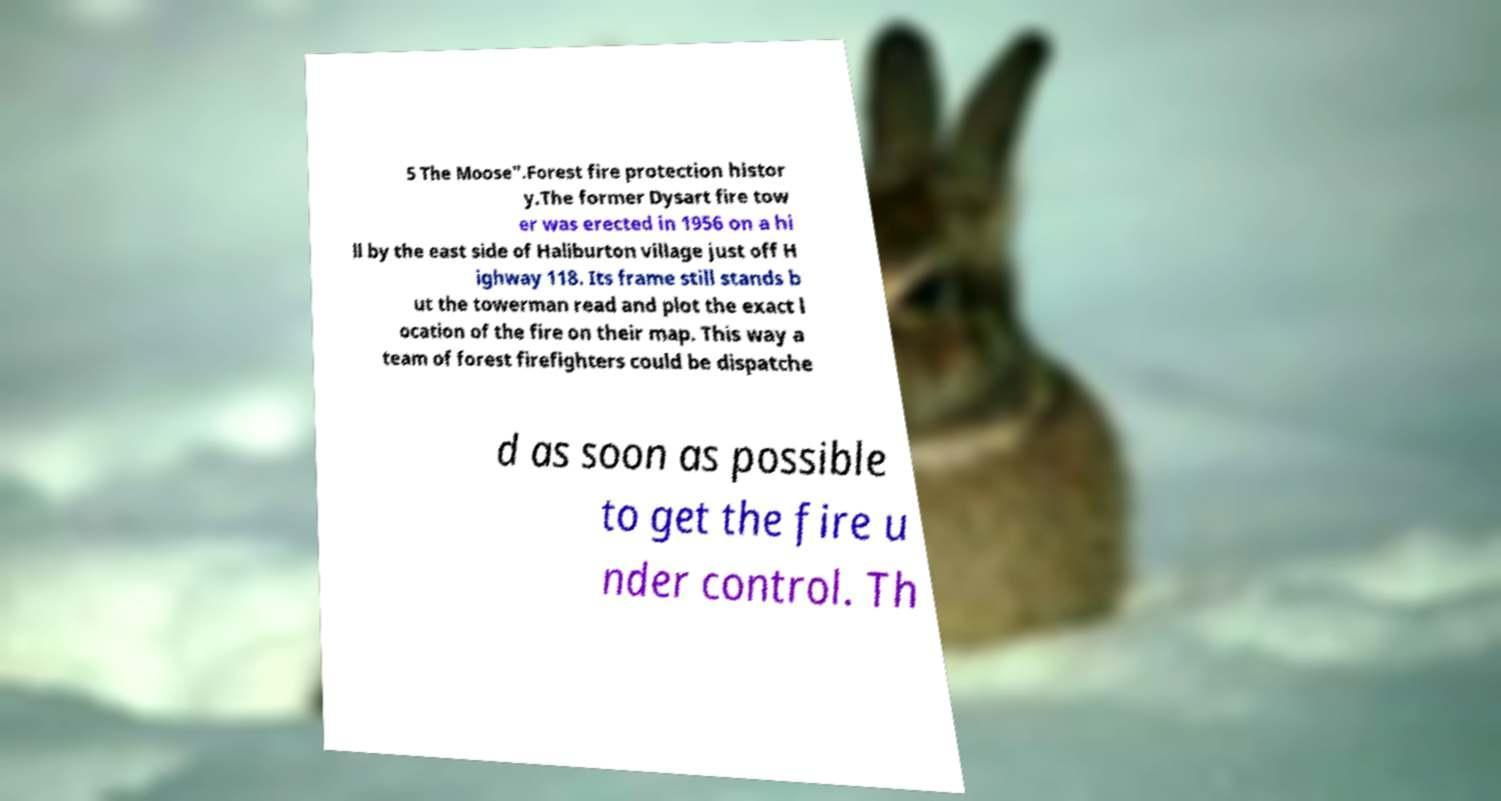Can you accurately transcribe the text from the provided image for me? 5 The Moose".Forest fire protection histor y.The former Dysart fire tow er was erected in 1956 on a hi ll by the east side of Haliburton village just off H ighway 118. Its frame still stands b ut the towerman read and plot the exact l ocation of the fire on their map. This way a team of forest firefighters could be dispatche d as soon as possible to get the fire u nder control. Th 